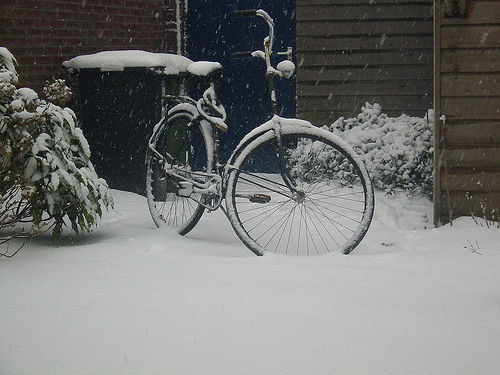What does the bicycle’s condition tell us about its recent use? The accumulation of snow on all surfaces of the bicycle suggests that it has not been used for the duration of the snowfall, indicating it has been stationary for at least several hours. The visible lack of tracks around the bike further reinforces that it hasn't been moved recently. 